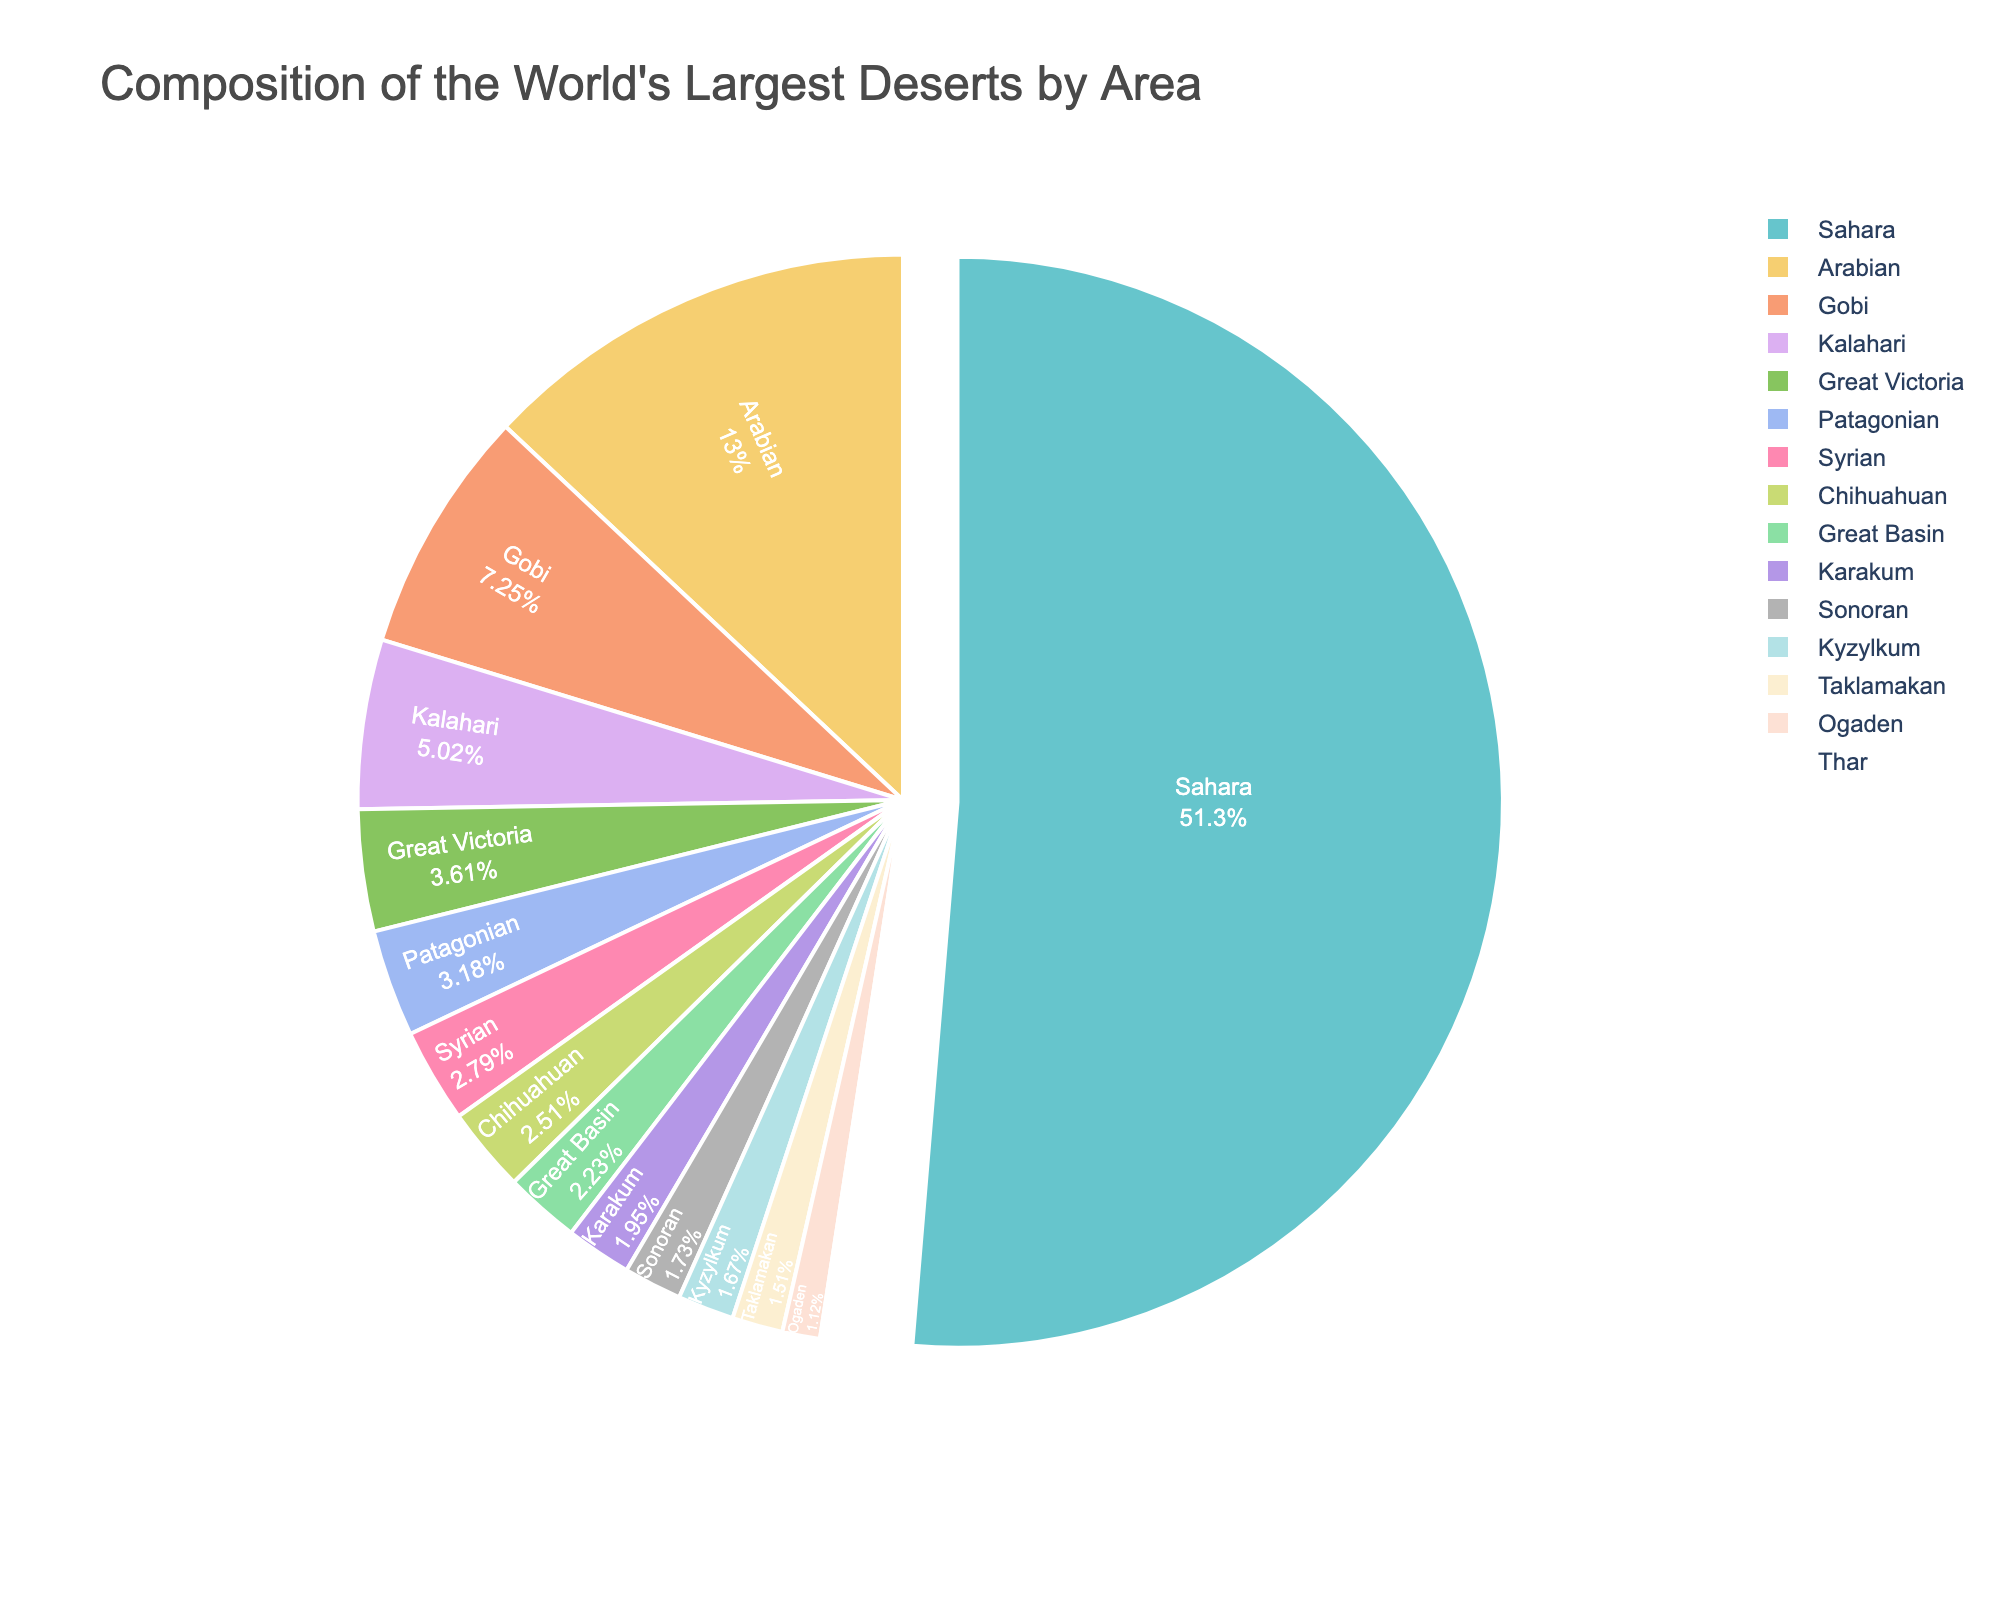Which desert has the biggest area? By looking at the pie chart, the largest segment corresponds to Sahara desert.
Answer: Sahara Which desert is the smallest by area? The smallest segment in the pie chart represents the Thar desert.
Answer: Thar What percentage of the total area is the Arabian desert? The pie chart divides the area into percentage segments and the Arabian desert's segment is shown to be 13.6%.
Answer: 13.6% How does the area of the Gobi desert compare to the Kalahari desert? The pie chart shows that the Gobi desert occupies a larger segment than the Kalahari desert.
Answer: Gobi is larger Which two deserts have areas closest in size? By examining the segments, the Great Basin (400,000 km²) and the Karakum (350,000 km²) are quite close in area.
Answer: Great Basin and Karakum What is the combined percentage of the Great Victoria and Patagonian deserts? The pie chart shows that Great Victoria is approximately 3.8% and Patagonian is 3.4%. Adding these together yields 7.2%.
Answer: 7.2% Does the Sonoran desert cover more or less area than the Kyzylkum desert? The pie chart shows the Sonoran desert occupying a slightly larger segment than the Kyzylkum desert.
Answer: More How does the percentage area of the Great Victoria desert compare to that of the Syrian desert? The chart indicates that the Great Victoria desert (3.8%) is slightly larger in percentage than the Syrian desert (2.9%).
Answer: Great Victoria is larger What is the difference in area between the Kalahari and the Patagonian deserts? The areas are 900,000 km² for Kalahari and 570,000 km² for Patagonian. The difference is 900,000 - 570,000 = 330,000 km².
Answer: 330,000 km² What is the median area of these deserts? Listing the areas in ascending order (200,000, 200,000, 270,000, 300,000, 310,000, 350,000, 400,000, 450,000, 500,000, 570,000, 647,000, 900,000, 1,300,000, 2,330,000, 9,200,000), the middle value is 450,000 km² (Chihuahuan).
Answer: 450,000 km² 